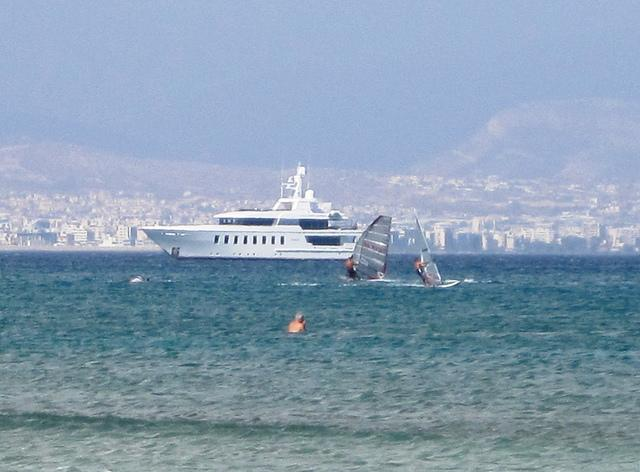How many people are holding onto parasail and sailing into the ocean?

Choices:
A) two
B) four
C) three
D) one two 